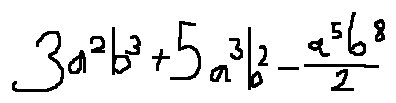<formula> <loc_0><loc_0><loc_500><loc_500>3 a ^ { 2 } b ^ { 3 } + 5 a ^ { 3 } b ^ { 2 } - \frac { a ^ { 5 } b ^ { 8 } } { 2 }</formula> 